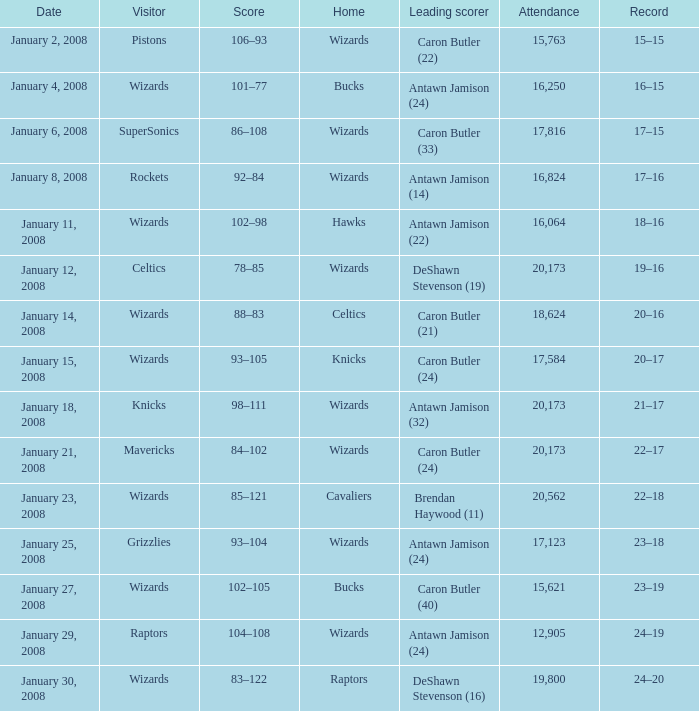What is the record when the highest scorer is antawn jamison (14)? 17–16. 